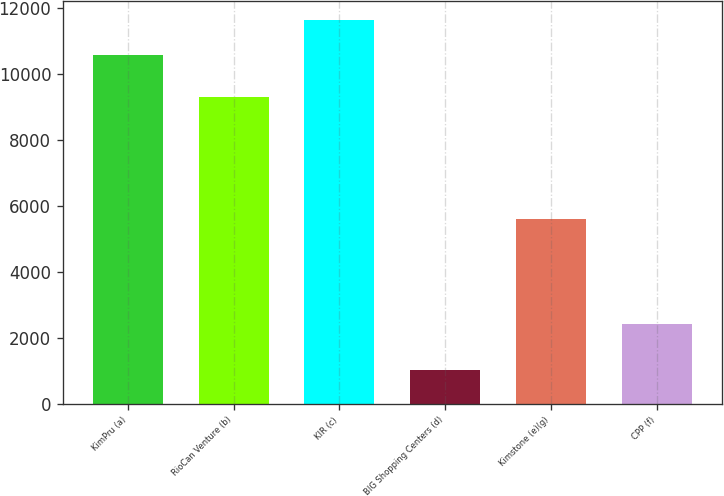Convert chart. <chart><loc_0><loc_0><loc_500><loc_500><bar_chart><fcel>KimPru (a)<fcel>RioCan Venture (b)<fcel>KIR (c)<fcel>BIG Shopping Centers (d)<fcel>Kimstone (e)(g)<fcel>CPP (f)<nl><fcel>10573<fcel>9307<fcel>11622<fcel>1029<fcel>5595<fcel>2425<nl></chart> 